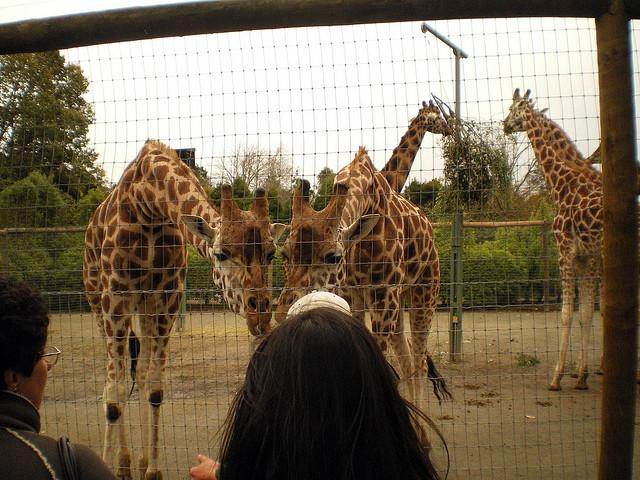What is the person on the left wearing?

Choices:
A) glasses
B) fedora
C) top hat
D) boa glasses 